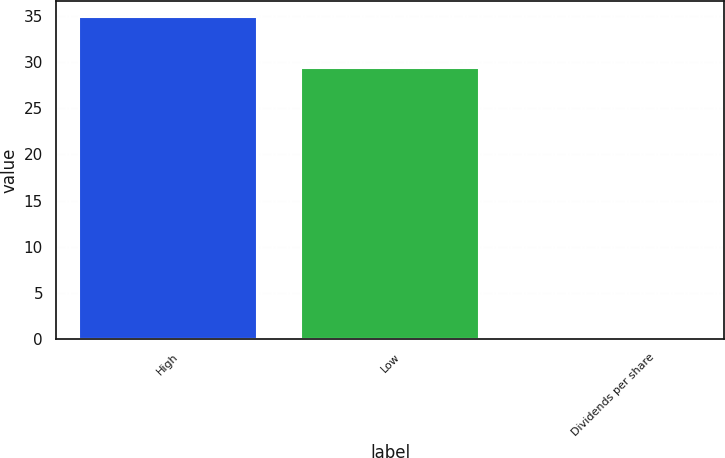Convert chart. <chart><loc_0><loc_0><loc_500><loc_500><bar_chart><fcel>High<fcel>Low<fcel>Dividends per share<nl><fcel>34.85<fcel>29.36<fcel>0.05<nl></chart> 